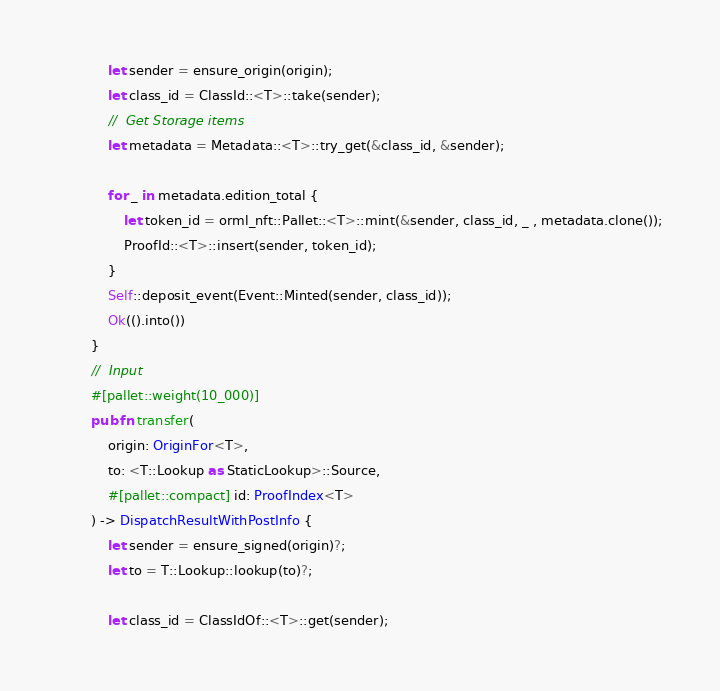Convert code to text. <code><loc_0><loc_0><loc_500><loc_500><_Rust_>			let sender = ensure_origin(origin);
			let class_id = ClassId::<T>::take(sender);
			//	Get Storage items
			let metadata = Metadata::<T>::try_get(&class_id, &sender);
			
			for _ in metadata.edition_total { 
				let token_id = orml_nft::Pallet::<T>::mint(&sender, class_id, _ , metadata.clone());
				ProofId::<T>::insert(sender, token_id);
			}
			Self::deposit_event(Event::Minted(sender, class_id));
			Ok(().into())
		}
		//	Input
		#[pallet::weight(10_000)]
		pub fn transfer(
			origin: OriginFor<T>,
			to: <T::Lookup as StaticLookup>::Source,
			#[pallet::compact] id: ProofIndex<T> 
		) -> DispatchResultWithPostInfo {
			let sender = ensure_signed(origin)?;
			let to = T::Lookup::lookup(to)?;
	
			let class_id = ClassIdOf::<T>::get(sender);</code> 